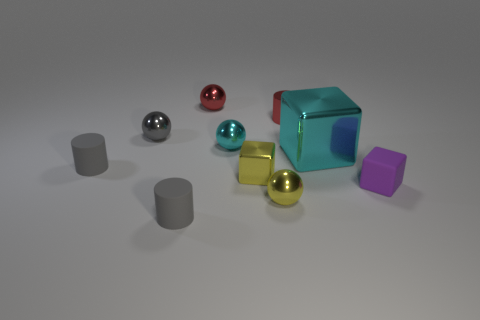Can you describe the different textures and colors present in the objects? Certainly! There are objects with both matte and metallic finishes. The metallic textures include a red sphere, a silver sphere, a turquoise block, and a gold sphere, while the matte objects comprise of three cylindrical shapes, one of which is gray, and one each of violet and yellow color.  Could you estimate how the lighting is affecting the appearance of these objects? The lighting seems to be coming from above, as indicated by the shadows beneath the objects and the subtle highlights on the tops of the metallic spheres and the block. This creates a soft appearance and reveals the contours and textures of the objects more distinctly. 